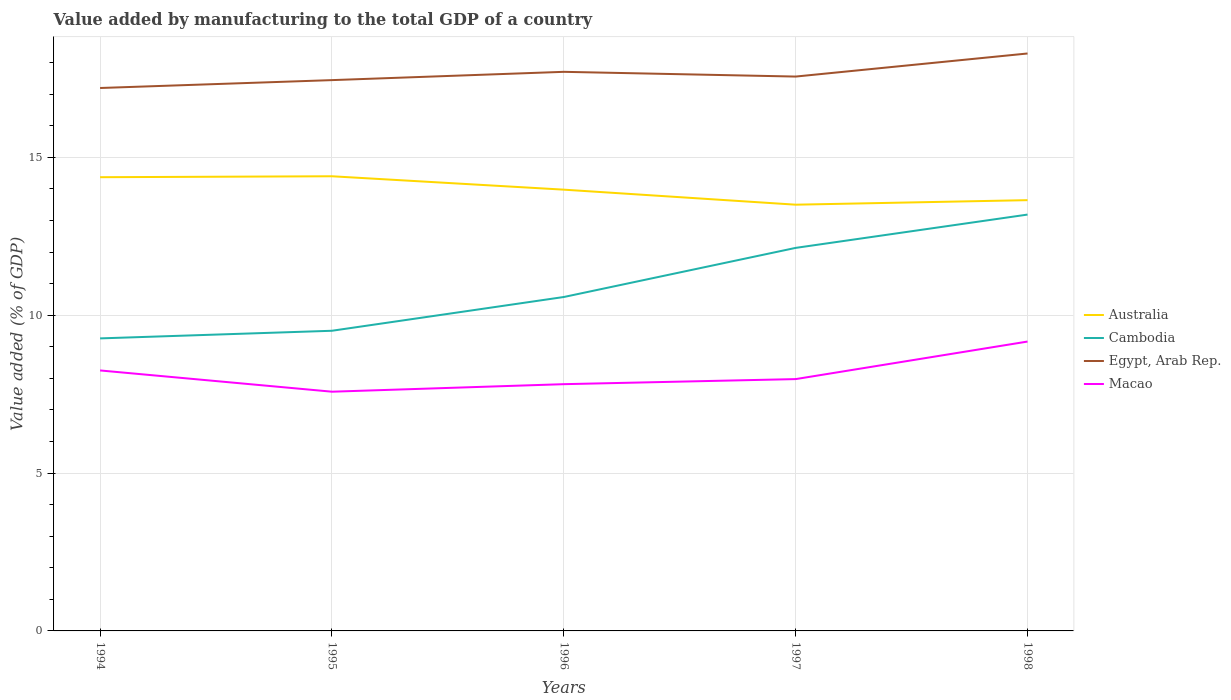How many different coloured lines are there?
Offer a very short reply. 4. Across all years, what is the maximum value added by manufacturing to the total GDP in Macao?
Your answer should be very brief. 7.58. What is the total value added by manufacturing to the total GDP in Australia in the graph?
Ensure brevity in your answer.  0.48. What is the difference between the highest and the second highest value added by manufacturing to the total GDP in Egypt, Arab Rep.?
Your answer should be very brief. 1.09. Is the value added by manufacturing to the total GDP in Macao strictly greater than the value added by manufacturing to the total GDP in Cambodia over the years?
Your answer should be compact. Yes. How many lines are there?
Keep it short and to the point. 4. What is the difference between two consecutive major ticks on the Y-axis?
Ensure brevity in your answer.  5. Are the values on the major ticks of Y-axis written in scientific E-notation?
Make the answer very short. No. How are the legend labels stacked?
Your answer should be compact. Vertical. What is the title of the graph?
Offer a terse response. Value added by manufacturing to the total GDP of a country. What is the label or title of the X-axis?
Provide a short and direct response. Years. What is the label or title of the Y-axis?
Provide a short and direct response. Value added (% of GDP). What is the Value added (% of GDP) of Australia in 1994?
Your response must be concise. 14.37. What is the Value added (% of GDP) of Cambodia in 1994?
Keep it short and to the point. 9.27. What is the Value added (% of GDP) of Egypt, Arab Rep. in 1994?
Offer a terse response. 17.2. What is the Value added (% of GDP) of Macao in 1994?
Your answer should be compact. 8.25. What is the Value added (% of GDP) in Australia in 1995?
Provide a short and direct response. 14.4. What is the Value added (% of GDP) of Cambodia in 1995?
Your response must be concise. 9.51. What is the Value added (% of GDP) of Egypt, Arab Rep. in 1995?
Give a very brief answer. 17.45. What is the Value added (% of GDP) of Macao in 1995?
Provide a succinct answer. 7.58. What is the Value added (% of GDP) in Australia in 1996?
Keep it short and to the point. 13.98. What is the Value added (% of GDP) of Cambodia in 1996?
Give a very brief answer. 10.58. What is the Value added (% of GDP) in Egypt, Arab Rep. in 1996?
Keep it short and to the point. 17.71. What is the Value added (% of GDP) of Macao in 1996?
Your response must be concise. 7.82. What is the Value added (% of GDP) of Australia in 1997?
Your response must be concise. 13.5. What is the Value added (% of GDP) of Cambodia in 1997?
Your response must be concise. 12.13. What is the Value added (% of GDP) in Egypt, Arab Rep. in 1997?
Offer a very short reply. 17.56. What is the Value added (% of GDP) in Macao in 1997?
Your answer should be compact. 7.98. What is the Value added (% of GDP) of Australia in 1998?
Make the answer very short. 13.65. What is the Value added (% of GDP) of Cambodia in 1998?
Keep it short and to the point. 13.19. What is the Value added (% of GDP) of Egypt, Arab Rep. in 1998?
Your answer should be very brief. 18.29. What is the Value added (% of GDP) in Macao in 1998?
Provide a short and direct response. 9.17. Across all years, what is the maximum Value added (% of GDP) in Australia?
Offer a very short reply. 14.4. Across all years, what is the maximum Value added (% of GDP) of Cambodia?
Make the answer very short. 13.19. Across all years, what is the maximum Value added (% of GDP) in Egypt, Arab Rep.?
Ensure brevity in your answer.  18.29. Across all years, what is the maximum Value added (% of GDP) in Macao?
Keep it short and to the point. 9.17. Across all years, what is the minimum Value added (% of GDP) of Australia?
Provide a short and direct response. 13.5. Across all years, what is the minimum Value added (% of GDP) in Cambodia?
Your answer should be very brief. 9.27. Across all years, what is the minimum Value added (% of GDP) in Egypt, Arab Rep.?
Make the answer very short. 17.2. Across all years, what is the minimum Value added (% of GDP) of Macao?
Offer a terse response. 7.58. What is the total Value added (% of GDP) in Australia in the graph?
Your answer should be compact. 69.91. What is the total Value added (% of GDP) of Cambodia in the graph?
Make the answer very short. 54.68. What is the total Value added (% of GDP) of Egypt, Arab Rep. in the graph?
Offer a very short reply. 88.22. What is the total Value added (% of GDP) in Macao in the graph?
Ensure brevity in your answer.  40.79. What is the difference between the Value added (% of GDP) of Australia in 1994 and that in 1995?
Your answer should be compact. -0.03. What is the difference between the Value added (% of GDP) in Cambodia in 1994 and that in 1995?
Your answer should be very brief. -0.24. What is the difference between the Value added (% of GDP) in Egypt, Arab Rep. in 1994 and that in 1995?
Your response must be concise. -0.25. What is the difference between the Value added (% of GDP) in Macao in 1994 and that in 1995?
Ensure brevity in your answer.  0.67. What is the difference between the Value added (% of GDP) of Australia in 1994 and that in 1996?
Your answer should be compact. 0.39. What is the difference between the Value added (% of GDP) of Cambodia in 1994 and that in 1996?
Provide a succinct answer. -1.31. What is the difference between the Value added (% of GDP) in Egypt, Arab Rep. in 1994 and that in 1996?
Your response must be concise. -0.51. What is the difference between the Value added (% of GDP) of Macao in 1994 and that in 1996?
Your answer should be very brief. 0.43. What is the difference between the Value added (% of GDP) of Australia in 1994 and that in 1997?
Offer a very short reply. 0.87. What is the difference between the Value added (% of GDP) of Cambodia in 1994 and that in 1997?
Your answer should be compact. -2.87. What is the difference between the Value added (% of GDP) of Egypt, Arab Rep. in 1994 and that in 1997?
Provide a short and direct response. -0.36. What is the difference between the Value added (% of GDP) in Macao in 1994 and that in 1997?
Keep it short and to the point. 0.27. What is the difference between the Value added (% of GDP) in Australia in 1994 and that in 1998?
Keep it short and to the point. 0.73. What is the difference between the Value added (% of GDP) in Cambodia in 1994 and that in 1998?
Ensure brevity in your answer.  -3.92. What is the difference between the Value added (% of GDP) of Egypt, Arab Rep. in 1994 and that in 1998?
Your answer should be very brief. -1.09. What is the difference between the Value added (% of GDP) in Macao in 1994 and that in 1998?
Ensure brevity in your answer.  -0.92. What is the difference between the Value added (% of GDP) in Australia in 1995 and that in 1996?
Give a very brief answer. 0.42. What is the difference between the Value added (% of GDP) of Cambodia in 1995 and that in 1996?
Your answer should be very brief. -1.07. What is the difference between the Value added (% of GDP) of Egypt, Arab Rep. in 1995 and that in 1996?
Ensure brevity in your answer.  -0.26. What is the difference between the Value added (% of GDP) in Macao in 1995 and that in 1996?
Ensure brevity in your answer.  -0.24. What is the difference between the Value added (% of GDP) of Australia in 1995 and that in 1997?
Ensure brevity in your answer.  0.9. What is the difference between the Value added (% of GDP) of Cambodia in 1995 and that in 1997?
Keep it short and to the point. -2.63. What is the difference between the Value added (% of GDP) of Egypt, Arab Rep. in 1995 and that in 1997?
Keep it short and to the point. -0.11. What is the difference between the Value added (% of GDP) of Macao in 1995 and that in 1997?
Ensure brevity in your answer.  -0.4. What is the difference between the Value added (% of GDP) of Australia in 1995 and that in 1998?
Your answer should be compact. 0.76. What is the difference between the Value added (% of GDP) of Cambodia in 1995 and that in 1998?
Your answer should be very brief. -3.68. What is the difference between the Value added (% of GDP) of Egypt, Arab Rep. in 1995 and that in 1998?
Your response must be concise. -0.84. What is the difference between the Value added (% of GDP) of Macao in 1995 and that in 1998?
Provide a succinct answer. -1.59. What is the difference between the Value added (% of GDP) of Australia in 1996 and that in 1997?
Offer a very short reply. 0.48. What is the difference between the Value added (% of GDP) of Cambodia in 1996 and that in 1997?
Your answer should be very brief. -1.56. What is the difference between the Value added (% of GDP) of Egypt, Arab Rep. in 1996 and that in 1997?
Your response must be concise. 0.15. What is the difference between the Value added (% of GDP) in Macao in 1996 and that in 1997?
Your response must be concise. -0.16. What is the difference between the Value added (% of GDP) of Australia in 1996 and that in 1998?
Your answer should be very brief. 0.33. What is the difference between the Value added (% of GDP) of Cambodia in 1996 and that in 1998?
Provide a succinct answer. -2.61. What is the difference between the Value added (% of GDP) of Egypt, Arab Rep. in 1996 and that in 1998?
Your answer should be very brief. -0.58. What is the difference between the Value added (% of GDP) of Macao in 1996 and that in 1998?
Make the answer very short. -1.35. What is the difference between the Value added (% of GDP) in Australia in 1997 and that in 1998?
Offer a terse response. -0.14. What is the difference between the Value added (% of GDP) of Cambodia in 1997 and that in 1998?
Keep it short and to the point. -1.06. What is the difference between the Value added (% of GDP) in Egypt, Arab Rep. in 1997 and that in 1998?
Your response must be concise. -0.73. What is the difference between the Value added (% of GDP) of Macao in 1997 and that in 1998?
Your response must be concise. -1.19. What is the difference between the Value added (% of GDP) in Australia in 1994 and the Value added (% of GDP) in Cambodia in 1995?
Provide a succinct answer. 4.86. What is the difference between the Value added (% of GDP) in Australia in 1994 and the Value added (% of GDP) in Egypt, Arab Rep. in 1995?
Make the answer very short. -3.08. What is the difference between the Value added (% of GDP) of Australia in 1994 and the Value added (% of GDP) of Macao in 1995?
Your answer should be compact. 6.79. What is the difference between the Value added (% of GDP) in Cambodia in 1994 and the Value added (% of GDP) in Egypt, Arab Rep. in 1995?
Provide a short and direct response. -8.18. What is the difference between the Value added (% of GDP) in Cambodia in 1994 and the Value added (% of GDP) in Macao in 1995?
Provide a succinct answer. 1.69. What is the difference between the Value added (% of GDP) of Egypt, Arab Rep. in 1994 and the Value added (% of GDP) of Macao in 1995?
Offer a very short reply. 9.62. What is the difference between the Value added (% of GDP) of Australia in 1994 and the Value added (% of GDP) of Cambodia in 1996?
Provide a short and direct response. 3.79. What is the difference between the Value added (% of GDP) of Australia in 1994 and the Value added (% of GDP) of Egypt, Arab Rep. in 1996?
Give a very brief answer. -3.34. What is the difference between the Value added (% of GDP) of Australia in 1994 and the Value added (% of GDP) of Macao in 1996?
Give a very brief answer. 6.56. What is the difference between the Value added (% of GDP) of Cambodia in 1994 and the Value added (% of GDP) of Egypt, Arab Rep. in 1996?
Your answer should be compact. -8.44. What is the difference between the Value added (% of GDP) in Cambodia in 1994 and the Value added (% of GDP) in Macao in 1996?
Provide a short and direct response. 1.45. What is the difference between the Value added (% of GDP) of Egypt, Arab Rep. in 1994 and the Value added (% of GDP) of Macao in 1996?
Offer a very short reply. 9.38. What is the difference between the Value added (% of GDP) of Australia in 1994 and the Value added (% of GDP) of Cambodia in 1997?
Offer a very short reply. 2.24. What is the difference between the Value added (% of GDP) of Australia in 1994 and the Value added (% of GDP) of Egypt, Arab Rep. in 1997?
Keep it short and to the point. -3.19. What is the difference between the Value added (% of GDP) in Australia in 1994 and the Value added (% of GDP) in Macao in 1997?
Your response must be concise. 6.4. What is the difference between the Value added (% of GDP) of Cambodia in 1994 and the Value added (% of GDP) of Egypt, Arab Rep. in 1997?
Make the answer very short. -8.29. What is the difference between the Value added (% of GDP) of Cambodia in 1994 and the Value added (% of GDP) of Macao in 1997?
Your response must be concise. 1.29. What is the difference between the Value added (% of GDP) of Egypt, Arab Rep. in 1994 and the Value added (% of GDP) of Macao in 1997?
Ensure brevity in your answer.  9.22. What is the difference between the Value added (% of GDP) in Australia in 1994 and the Value added (% of GDP) in Cambodia in 1998?
Make the answer very short. 1.18. What is the difference between the Value added (% of GDP) of Australia in 1994 and the Value added (% of GDP) of Egypt, Arab Rep. in 1998?
Make the answer very short. -3.92. What is the difference between the Value added (% of GDP) of Australia in 1994 and the Value added (% of GDP) of Macao in 1998?
Ensure brevity in your answer.  5.21. What is the difference between the Value added (% of GDP) in Cambodia in 1994 and the Value added (% of GDP) in Egypt, Arab Rep. in 1998?
Your answer should be compact. -9.03. What is the difference between the Value added (% of GDP) in Cambodia in 1994 and the Value added (% of GDP) in Macao in 1998?
Keep it short and to the point. 0.1. What is the difference between the Value added (% of GDP) in Egypt, Arab Rep. in 1994 and the Value added (% of GDP) in Macao in 1998?
Keep it short and to the point. 8.03. What is the difference between the Value added (% of GDP) in Australia in 1995 and the Value added (% of GDP) in Cambodia in 1996?
Offer a terse response. 3.82. What is the difference between the Value added (% of GDP) of Australia in 1995 and the Value added (% of GDP) of Egypt, Arab Rep. in 1996?
Offer a terse response. -3.31. What is the difference between the Value added (% of GDP) of Australia in 1995 and the Value added (% of GDP) of Macao in 1996?
Offer a very short reply. 6.59. What is the difference between the Value added (% of GDP) of Cambodia in 1995 and the Value added (% of GDP) of Egypt, Arab Rep. in 1996?
Make the answer very short. -8.2. What is the difference between the Value added (% of GDP) in Cambodia in 1995 and the Value added (% of GDP) in Macao in 1996?
Provide a short and direct response. 1.69. What is the difference between the Value added (% of GDP) of Egypt, Arab Rep. in 1995 and the Value added (% of GDP) of Macao in 1996?
Make the answer very short. 9.63. What is the difference between the Value added (% of GDP) of Australia in 1995 and the Value added (% of GDP) of Cambodia in 1997?
Your answer should be compact. 2.27. What is the difference between the Value added (% of GDP) of Australia in 1995 and the Value added (% of GDP) of Egypt, Arab Rep. in 1997?
Your answer should be compact. -3.16. What is the difference between the Value added (% of GDP) of Australia in 1995 and the Value added (% of GDP) of Macao in 1997?
Give a very brief answer. 6.43. What is the difference between the Value added (% of GDP) of Cambodia in 1995 and the Value added (% of GDP) of Egypt, Arab Rep. in 1997?
Make the answer very short. -8.05. What is the difference between the Value added (% of GDP) of Cambodia in 1995 and the Value added (% of GDP) of Macao in 1997?
Ensure brevity in your answer.  1.53. What is the difference between the Value added (% of GDP) in Egypt, Arab Rep. in 1995 and the Value added (% of GDP) in Macao in 1997?
Keep it short and to the point. 9.47. What is the difference between the Value added (% of GDP) of Australia in 1995 and the Value added (% of GDP) of Cambodia in 1998?
Your answer should be compact. 1.21. What is the difference between the Value added (% of GDP) of Australia in 1995 and the Value added (% of GDP) of Egypt, Arab Rep. in 1998?
Your answer should be very brief. -3.89. What is the difference between the Value added (% of GDP) in Australia in 1995 and the Value added (% of GDP) in Macao in 1998?
Ensure brevity in your answer.  5.24. What is the difference between the Value added (% of GDP) in Cambodia in 1995 and the Value added (% of GDP) in Egypt, Arab Rep. in 1998?
Provide a succinct answer. -8.78. What is the difference between the Value added (% of GDP) in Cambodia in 1995 and the Value added (% of GDP) in Macao in 1998?
Your response must be concise. 0.34. What is the difference between the Value added (% of GDP) of Egypt, Arab Rep. in 1995 and the Value added (% of GDP) of Macao in 1998?
Provide a succinct answer. 8.28. What is the difference between the Value added (% of GDP) in Australia in 1996 and the Value added (% of GDP) in Cambodia in 1997?
Your response must be concise. 1.84. What is the difference between the Value added (% of GDP) of Australia in 1996 and the Value added (% of GDP) of Egypt, Arab Rep. in 1997?
Your response must be concise. -3.58. What is the difference between the Value added (% of GDP) of Australia in 1996 and the Value added (% of GDP) of Macao in 1997?
Make the answer very short. 6. What is the difference between the Value added (% of GDP) in Cambodia in 1996 and the Value added (% of GDP) in Egypt, Arab Rep. in 1997?
Provide a short and direct response. -6.98. What is the difference between the Value added (% of GDP) of Cambodia in 1996 and the Value added (% of GDP) of Macao in 1997?
Provide a short and direct response. 2.6. What is the difference between the Value added (% of GDP) in Egypt, Arab Rep. in 1996 and the Value added (% of GDP) in Macao in 1997?
Give a very brief answer. 9.73. What is the difference between the Value added (% of GDP) in Australia in 1996 and the Value added (% of GDP) in Cambodia in 1998?
Make the answer very short. 0.79. What is the difference between the Value added (% of GDP) in Australia in 1996 and the Value added (% of GDP) in Egypt, Arab Rep. in 1998?
Your response must be concise. -4.31. What is the difference between the Value added (% of GDP) in Australia in 1996 and the Value added (% of GDP) in Macao in 1998?
Keep it short and to the point. 4.81. What is the difference between the Value added (% of GDP) in Cambodia in 1996 and the Value added (% of GDP) in Egypt, Arab Rep. in 1998?
Your answer should be very brief. -7.71. What is the difference between the Value added (% of GDP) in Cambodia in 1996 and the Value added (% of GDP) in Macao in 1998?
Give a very brief answer. 1.41. What is the difference between the Value added (% of GDP) in Egypt, Arab Rep. in 1996 and the Value added (% of GDP) in Macao in 1998?
Give a very brief answer. 8.54. What is the difference between the Value added (% of GDP) in Australia in 1997 and the Value added (% of GDP) in Cambodia in 1998?
Keep it short and to the point. 0.31. What is the difference between the Value added (% of GDP) in Australia in 1997 and the Value added (% of GDP) in Egypt, Arab Rep. in 1998?
Offer a terse response. -4.79. What is the difference between the Value added (% of GDP) in Australia in 1997 and the Value added (% of GDP) in Macao in 1998?
Your answer should be compact. 4.34. What is the difference between the Value added (% of GDP) in Cambodia in 1997 and the Value added (% of GDP) in Egypt, Arab Rep. in 1998?
Provide a succinct answer. -6.16. What is the difference between the Value added (% of GDP) in Cambodia in 1997 and the Value added (% of GDP) in Macao in 1998?
Provide a succinct answer. 2.97. What is the difference between the Value added (% of GDP) of Egypt, Arab Rep. in 1997 and the Value added (% of GDP) of Macao in 1998?
Keep it short and to the point. 8.39. What is the average Value added (% of GDP) of Australia per year?
Provide a succinct answer. 13.98. What is the average Value added (% of GDP) of Cambodia per year?
Your answer should be compact. 10.94. What is the average Value added (% of GDP) of Egypt, Arab Rep. per year?
Provide a succinct answer. 17.64. What is the average Value added (% of GDP) in Macao per year?
Give a very brief answer. 8.16. In the year 1994, what is the difference between the Value added (% of GDP) of Australia and Value added (% of GDP) of Cambodia?
Provide a succinct answer. 5.11. In the year 1994, what is the difference between the Value added (% of GDP) in Australia and Value added (% of GDP) in Egypt, Arab Rep.?
Your response must be concise. -2.83. In the year 1994, what is the difference between the Value added (% of GDP) in Australia and Value added (% of GDP) in Macao?
Give a very brief answer. 6.12. In the year 1994, what is the difference between the Value added (% of GDP) of Cambodia and Value added (% of GDP) of Egypt, Arab Rep.?
Your response must be concise. -7.93. In the year 1994, what is the difference between the Value added (% of GDP) in Cambodia and Value added (% of GDP) in Macao?
Your answer should be very brief. 1.02. In the year 1994, what is the difference between the Value added (% of GDP) of Egypt, Arab Rep. and Value added (% of GDP) of Macao?
Your response must be concise. 8.95. In the year 1995, what is the difference between the Value added (% of GDP) of Australia and Value added (% of GDP) of Cambodia?
Provide a succinct answer. 4.89. In the year 1995, what is the difference between the Value added (% of GDP) in Australia and Value added (% of GDP) in Egypt, Arab Rep.?
Keep it short and to the point. -3.05. In the year 1995, what is the difference between the Value added (% of GDP) of Australia and Value added (% of GDP) of Macao?
Provide a short and direct response. 6.82. In the year 1995, what is the difference between the Value added (% of GDP) in Cambodia and Value added (% of GDP) in Egypt, Arab Rep.?
Your answer should be very brief. -7.94. In the year 1995, what is the difference between the Value added (% of GDP) of Cambodia and Value added (% of GDP) of Macao?
Provide a short and direct response. 1.93. In the year 1995, what is the difference between the Value added (% of GDP) of Egypt, Arab Rep. and Value added (% of GDP) of Macao?
Give a very brief answer. 9.87. In the year 1996, what is the difference between the Value added (% of GDP) of Australia and Value added (% of GDP) of Cambodia?
Ensure brevity in your answer.  3.4. In the year 1996, what is the difference between the Value added (% of GDP) of Australia and Value added (% of GDP) of Egypt, Arab Rep.?
Make the answer very short. -3.73. In the year 1996, what is the difference between the Value added (% of GDP) in Australia and Value added (% of GDP) in Macao?
Offer a terse response. 6.16. In the year 1996, what is the difference between the Value added (% of GDP) of Cambodia and Value added (% of GDP) of Egypt, Arab Rep.?
Ensure brevity in your answer.  -7.13. In the year 1996, what is the difference between the Value added (% of GDP) in Cambodia and Value added (% of GDP) in Macao?
Give a very brief answer. 2.76. In the year 1996, what is the difference between the Value added (% of GDP) in Egypt, Arab Rep. and Value added (% of GDP) in Macao?
Provide a succinct answer. 9.89. In the year 1997, what is the difference between the Value added (% of GDP) in Australia and Value added (% of GDP) in Cambodia?
Ensure brevity in your answer.  1.37. In the year 1997, what is the difference between the Value added (% of GDP) in Australia and Value added (% of GDP) in Egypt, Arab Rep.?
Your answer should be very brief. -4.06. In the year 1997, what is the difference between the Value added (% of GDP) in Australia and Value added (% of GDP) in Macao?
Your response must be concise. 5.53. In the year 1997, what is the difference between the Value added (% of GDP) in Cambodia and Value added (% of GDP) in Egypt, Arab Rep.?
Provide a succinct answer. -5.43. In the year 1997, what is the difference between the Value added (% of GDP) of Cambodia and Value added (% of GDP) of Macao?
Your answer should be compact. 4.16. In the year 1997, what is the difference between the Value added (% of GDP) in Egypt, Arab Rep. and Value added (% of GDP) in Macao?
Give a very brief answer. 9.58. In the year 1998, what is the difference between the Value added (% of GDP) of Australia and Value added (% of GDP) of Cambodia?
Your answer should be very brief. 0.46. In the year 1998, what is the difference between the Value added (% of GDP) of Australia and Value added (% of GDP) of Egypt, Arab Rep.?
Give a very brief answer. -4.65. In the year 1998, what is the difference between the Value added (% of GDP) in Australia and Value added (% of GDP) in Macao?
Ensure brevity in your answer.  4.48. In the year 1998, what is the difference between the Value added (% of GDP) in Cambodia and Value added (% of GDP) in Egypt, Arab Rep.?
Your response must be concise. -5.1. In the year 1998, what is the difference between the Value added (% of GDP) of Cambodia and Value added (% of GDP) of Macao?
Make the answer very short. 4.02. In the year 1998, what is the difference between the Value added (% of GDP) of Egypt, Arab Rep. and Value added (% of GDP) of Macao?
Offer a terse response. 9.13. What is the ratio of the Value added (% of GDP) in Cambodia in 1994 to that in 1995?
Provide a succinct answer. 0.97. What is the ratio of the Value added (% of GDP) of Egypt, Arab Rep. in 1994 to that in 1995?
Make the answer very short. 0.99. What is the ratio of the Value added (% of GDP) of Macao in 1994 to that in 1995?
Your answer should be compact. 1.09. What is the ratio of the Value added (% of GDP) in Australia in 1994 to that in 1996?
Offer a terse response. 1.03. What is the ratio of the Value added (% of GDP) in Cambodia in 1994 to that in 1996?
Offer a very short reply. 0.88. What is the ratio of the Value added (% of GDP) of Egypt, Arab Rep. in 1994 to that in 1996?
Your response must be concise. 0.97. What is the ratio of the Value added (% of GDP) of Macao in 1994 to that in 1996?
Your answer should be very brief. 1.06. What is the ratio of the Value added (% of GDP) in Australia in 1994 to that in 1997?
Your answer should be very brief. 1.06. What is the ratio of the Value added (% of GDP) of Cambodia in 1994 to that in 1997?
Offer a very short reply. 0.76. What is the ratio of the Value added (% of GDP) of Egypt, Arab Rep. in 1994 to that in 1997?
Your answer should be very brief. 0.98. What is the ratio of the Value added (% of GDP) of Macao in 1994 to that in 1997?
Offer a very short reply. 1.03. What is the ratio of the Value added (% of GDP) of Australia in 1994 to that in 1998?
Provide a short and direct response. 1.05. What is the ratio of the Value added (% of GDP) in Cambodia in 1994 to that in 1998?
Your response must be concise. 0.7. What is the ratio of the Value added (% of GDP) of Egypt, Arab Rep. in 1994 to that in 1998?
Provide a succinct answer. 0.94. What is the ratio of the Value added (% of GDP) of Macao in 1994 to that in 1998?
Your response must be concise. 0.9. What is the ratio of the Value added (% of GDP) of Australia in 1995 to that in 1996?
Give a very brief answer. 1.03. What is the ratio of the Value added (% of GDP) of Cambodia in 1995 to that in 1996?
Offer a very short reply. 0.9. What is the ratio of the Value added (% of GDP) in Egypt, Arab Rep. in 1995 to that in 1996?
Offer a terse response. 0.99. What is the ratio of the Value added (% of GDP) of Macao in 1995 to that in 1996?
Provide a short and direct response. 0.97. What is the ratio of the Value added (% of GDP) in Australia in 1995 to that in 1997?
Offer a terse response. 1.07. What is the ratio of the Value added (% of GDP) in Cambodia in 1995 to that in 1997?
Ensure brevity in your answer.  0.78. What is the ratio of the Value added (% of GDP) in Egypt, Arab Rep. in 1995 to that in 1997?
Your answer should be very brief. 0.99. What is the ratio of the Value added (% of GDP) of Australia in 1995 to that in 1998?
Offer a terse response. 1.06. What is the ratio of the Value added (% of GDP) in Cambodia in 1995 to that in 1998?
Your answer should be very brief. 0.72. What is the ratio of the Value added (% of GDP) in Egypt, Arab Rep. in 1995 to that in 1998?
Make the answer very short. 0.95. What is the ratio of the Value added (% of GDP) in Macao in 1995 to that in 1998?
Provide a short and direct response. 0.83. What is the ratio of the Value added (% of GDP) of Australia in 1996 to that in 1997?
Keep it short and to the point. 1.04. What is the ratio of the Value added (% of GDP) in Cambodia in 1996 to that in 1997?
Your answer should be compact. 0.87. What is the ratio of the Value added (% of GDP) of Egypt, Arab Rep. in 1996 to that in 1997?
Offer a terse response. 1.01. What is the ratio of the Value added (% of GDP) in Macao in 1996 to that in 1997?
Offer a terse response. 0.98. What is the ratio of the Value added (% of GDP) in Australia in 1996 to that in 1998?
Offer a terse response. 1.02. What is the ratio of the Value added (% of GDP) of Cambodia in 1996 to that in 1998?
Your response must be concise. 0.8. What is the ratio of the Value added (% of GDP) of Egypt, Arab Rep. in 1996 to that in 1998?
Your answer should be compact. 0.97. What is the ratio of the Value added (% of GDP) of Macao in 1996 to that in 1998?
Make the answer very short. 0.85. What is the ratio of the Value added (% of GDP) of Australia in 1997 to that in 1998?
Keep it short and to the point. 0.99. What is the ratio of the Value added (% of GDP) of Cambodia in 1997 to that in 1998?
Your answer should be very brief. 0.92. What is the ratio of the Value added (% of GDP) in Macao in 1997 to that in 1998?
Keep it short and to the point. 0.87. What is the difference between the highest and the second highest Value added (% of GDP) in Australia?
Ensure brevity in your answer.  0.03. What is the difference between the highest and the second highest Value added (% of GDP) of Cambodia?
Your response must be concise. 1.06. What is the difference between the highest and the second highest Value added (% of GDP) in Egypt, Arab Rep.?
Provide a succinct answer. 0.58. What is the difference between the highest and the second highest Value added (% of GDP) of Macao?
Ensure brevity in your answer.  0.92. What is the difference between the highest and the lowest Value added (% of GDP) of Australia?
Make the answer very short. 0.9. What is the difference between the highest and the lowest Value added (% of GDP) of Cambodia?
Keep it short and to the point. 3.92. What is the difference between the highest and the lowest Value added (% of GDP) of Egypt, Arab Rep.?
Make the answer very short. 1.09. What is the difference between the highest and the lowest Value added (% of GDP) in Macao?
Keep it short and to the point. 1.59. 